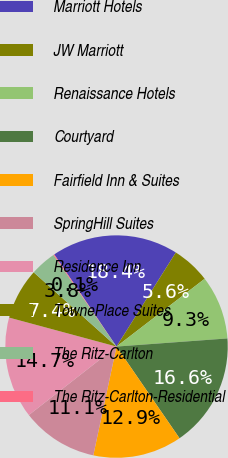Convert chart to OTSL. <chart><loc_0><loc_0><loc_500><loc_500><pie_chart><fcel>Marriott Hotels<fcel>JW Marriott<fcel>Renaissance Hotels<fcel>Courtyard<fcel>Fairfield Inn & Suites<fcel>SpringHill Suites<fcel>Residence Inn<fcel>TownePlace Suites<fcel>The Ritz-Carlton<fcel>The Ritz-Carlton-Residential<nl><fcel>18.41%<fcel>5.61%<fcel>9.27%<fcel>16.58%<fcel>12.93%<fcel>11.1%<fcel>14.75%<fcel>7.44%<fcel>3.78%<fcel>0.13%<nl></chart> 